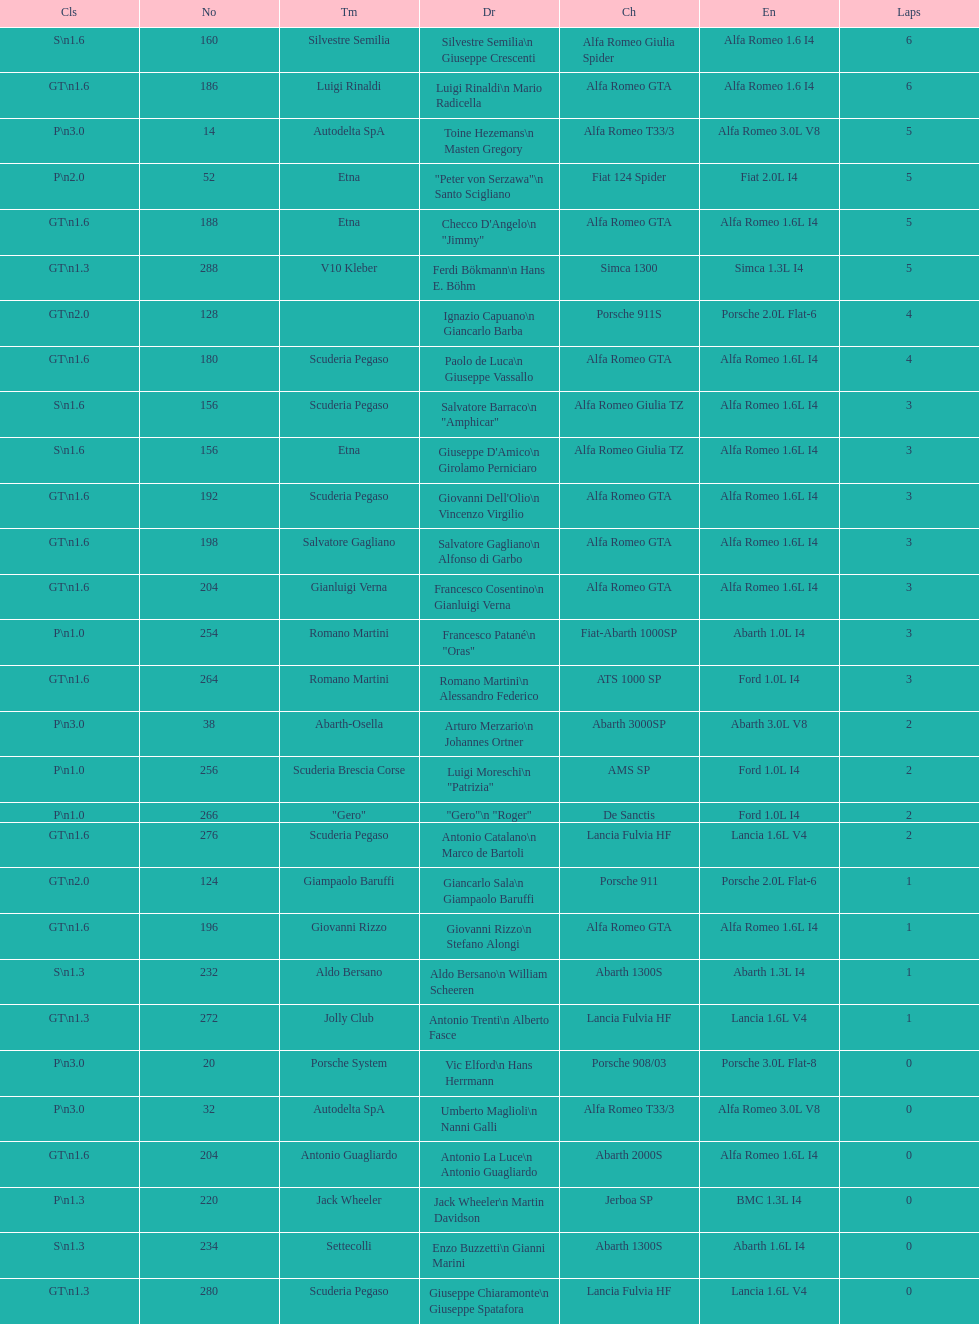What class is below s 1.6? GT 1.6. 